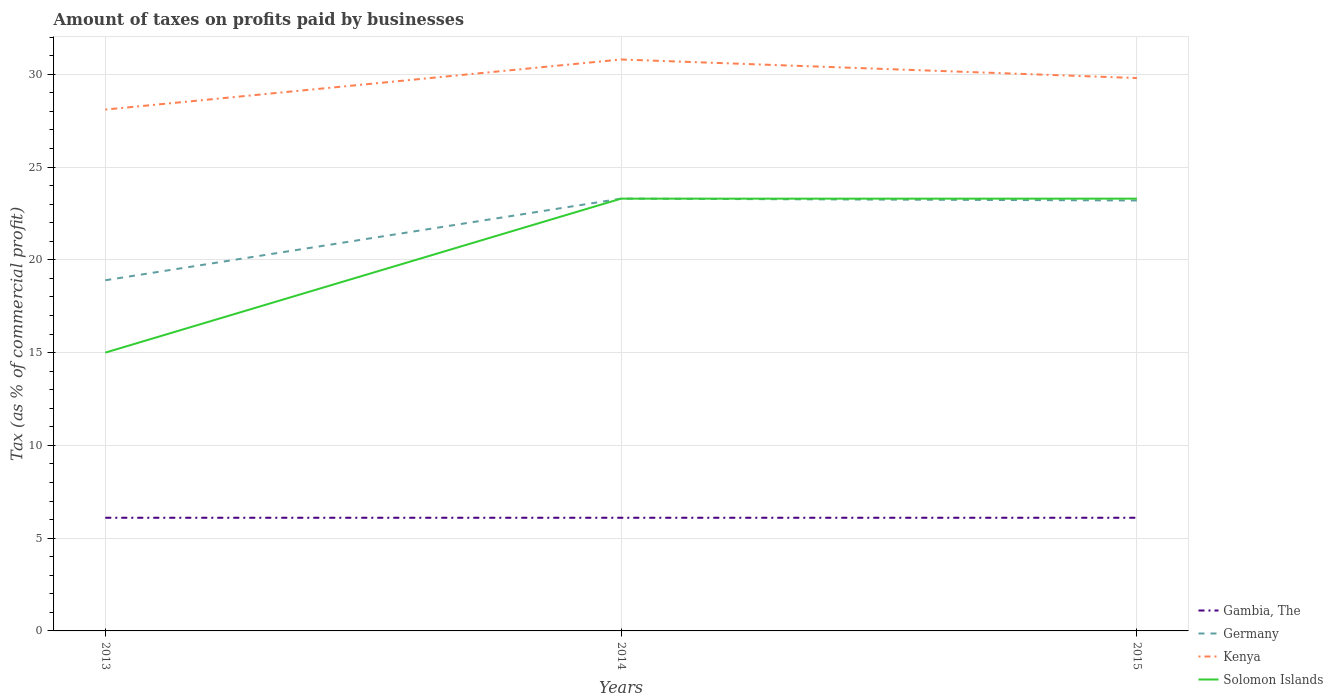Across all years, what is the maximum percentage of taxes paid by businesses in Germany?
Offer a terse response. 18.9. In which year was the percentage of taxes paid by businesses in Kenya maximum?
Keep it short and to the point. 2013. What is the total percentage of taxes paid by businesses in Germany in the graph?
Offer a terse response. 0.1. What is the difference between the highest and the second highest percentage of taxes paid by businesses in Kenya?
Make the answer very short. 2.7. Is the percentage of taxes paid by businesses in Germany strictly greater than the percentage of taxes paid by businesses in Kenya over the years?
Make the answer very short. Yes. Does the graph contain grids?
Your answer should be very brief. Yes. How many legend labels are there?
Your answer should be very brief. 4. How are the legend labels stacked?
Offer a terse response. Vertical. What is the title of the graph?
Your response must be concise. Amount of taxes on profits paid by businesses. What is the label or title of the Y-axis?
Ensure brevity in your answer.  Tax (as % of commercial profit). What is the Tax (as % of commercial profit) in Germany in 2013?
Give a very brief answer. 18.9. What is the Tax (as % of commercial profit) of Kenya in 2013?
Give a very brief answer. 28.1. What is the Tax (as % of commercial profit) of Germany in 2014?
Keep it short and to the point. 23.3. What is the Tax (as % of commercial profit) in Kenya in 2014?
Keep it short and to the point. 30.8. What is the Tax (as % of commercial profit) of Solomon Islands in 2014?
Keep it short and to the point. 23.3. What is the Tax (as % of commercial profit) of Germany in 2015?
Your answer should be compact. 23.2. What is the Tax (as % of commercial profit) of Kenya in 2015?
Ensure brevity in your answer.  29.8. What is the Tax (as % of commercial profit) of Solomon Islands in 2015?
Keep it short and to the point. 23.3. Across all years, what is the maximum Tax (as % of commercial profit) of Germany?
Give a very brief answer. 23.3. Across all years, what is the maximum Tax (as % of commercial profit) of Kenya?
Ensure brevity in your answer.  30.8. Across all years, what is the maximum Tax (as % of commercial profit) of Solomon Islands?
Provide a short and direct response. 23.3. Across all years, what is the minimum Tax (as % of commercial profit) of Gambia, The?
Ensure brevity in your answer.  6.1. Across all years, what is the minimum Tax (as % of commercial profit) of Kenya?
Your response must be concise. 28.1. What is the total Tax (as % of commercial profit) in Gambia, The in the graph?
Give a very brief answer. 18.3. What is the total Tax (as % of commercial profit) of Germany in the graph?
Keep it short and to the point. 65.4. What is the total Tax (as % of commercial profit) in Kenya in the graph?
Offer a very short reply. 88.7. What is the total Tax (as % of commercial profit) of Solomon Islands in the graph?
Provide a short and direct response. 61.6. What is the difference between the Tax (as % of commercial profit) of Gambia, The in 2013 and that in 2014?
Offer a terse response. 0. What is the difference between the Tax (as % of commercial profit) of Solomon Islands in 2013 and that in 2014?
Give a very brief answer. -8.3. What is the difference between the Tax (as % of commercial profit) of Gambia, The in 2013 and that in 2015?
Offer a very short reply. 0. What is the difference between the Tax (as % of commercial profit) in Solomon Islands in 2013 and that in 2015?
Provide a short and direct response. -8.3. What is the difference between the Tax (as % of commercial profit) in Gambia, The in 2014 and that in 2015?
Your answer should be compact. 0. What is the difference between the Tax (as % of commercial profit) in Solomon Islands in 2014 and that in 2015?
Keep it short and to the point. 0. What is the difference between the Tax (as % of commercial profit) of Gambia, The in 2013 and the Tax (as % of commercial profit) of Germany in 2014?
Give a very brief answer. -17.2. What is the difference between the Tax (as % of commercial profit) in Gambia, The in 2013 and the Tax (as % of commercial profit) in Kenya in 2014?
Offer a very short reply. -24.7. What is the difference between the Tax (as % of commercial profit) in Gambia, The in 2013 and the Tax (as % of commercial profit) in Solomon Islands in 2014?
Ensure brevity in your answer.  -17.2. What is the difference between the Tax (as % of commercial profit) of Germany in 2013 and the Tax (as % of commercial profit) of Kenya in 2014?
Provide a short and direct response. -11.9. What is the difference between the Tax (as % of commercial profit) in Germany in 2013 and the Tax (as % of commercial profit) in Solomon Islands in 2014?
Your answer should be very brief. -4.4. What is the difference between the Tax (as % of commercial profit) in Kenya in 2013 and the Tax (as % of commercial profit) in Solomon Islands in 2014?
Provide a succinct answer. 4.8. What is the difference between the Tax (as % of commercial profit) of Gambia, The in 2013 and the Tax (as % of commercial profit) of Germany in 2015?
Make the answer very short. -17.1. What is the difference between the Tax (as % of commercial profit) of Gambia, The in 2013 and the Tax (as % of commercial profit) of Kenya in 2015?
Ensure brevity in your answer.  -23.7. What is the difference between the Tax (as % of commercial profit) of Gambia, The in 2013 and the Tax (as % of commercial profit) of Solomon Islands in 2015?
Offer a very short reply. -17.2. What is the difference between the Tax (as % of commercial profit) of Germany in 2013 and the Tax (as % of commercial profit) of Kenya in 2015?
Offer a terse response. -10.9. What is the difference between the Tax (as % of commercial profit) of Germany in 2013 and the Tax (as % of commercial profit) of Solomon Islands in 2015?
Your answer should be very brief. -4.4. What is the difference between the Tax (as % of commercial profit) in Kenya in 2013 and the Tax (as % of commercial profit) in Solomon Islands in 2015?
Offer a terse response. 4.8. What is the difference between the Tax (as % of commercial profit) of Gambia, The in 2014 and the Tax (as % of commercial profit) of Germany in 2015?
Provide a short and direct response. -17.1. What is the difference between the Tax (as % of commercial profit) in Gambia, The in 2014 and the Tax (as % of commercial profit) in Kenya in 2015?
Offer a very short reply. -23.7. What is the difference between the Tax (as % of commercial profit) of Gambia, The in 2014 and the Tax (as % of commercial profit) of Solomon Islands in 2015?
Offer a very short reply. -17.2. What is the difference between the Tax (as % of commercial profit) of Germany in 2014 and the Tax (as % of commercial profit) of Kenya in 2015?
Give a very brief answer. -6.5. What is the difference between the Tax (as % of commercial profit) of Germany in 2014 and the Tax (as % of commercial profit) of Solomon Islands in 2015?
Provide a succinct answer. 0. What is the difference between the Tax (as % of commercial profit) of Kenya in 2014 and the Tax (as % of commercial profit) of Solomon Islands in 2015?
Your answer should be compact. 7.5. What is the average Tax (as % of commercial profit) of Gambia, The per year?
Provide a short and direct response. 6.1. What is the average Tax (as % of commercial profit) in Germany per year?
Provide a short and direct response. 21.8. What is the average Tax (as % of commercial profit) in Kenya per year?
Your answer should be compact. 29.57. What is the average Tax (as % of commercial profit) in Solomon Islands per year?
Provide a short and direct response. 20.53. In the year 2013, what is the difference between the Tax (as % of commercial profit) in Gambia, The and Tax (as % of commercial profit) in Germany?
Provide a succinct answer. -12.8. In the year 2013, what is the difference between the Tax (as % of commercial profit) of Germany and Tax (as % of commercial profit) of Solomon Islands?
Provide a succinct answer. 3.9. In the year 2013, what is the difference between the Tax (as % of commercial profit) in Kenya and Tax (as % of commercial profit) in Solomon Islands?
Ensure brevity in your answer.  13.1. In the year 2014, what is the difference between the Tax (as % of commercial profit) of Gambia, The and Tax (as % of commercial profit) of Germany?
Ensure brevity in your answer.  -17.2. In the year 2014, what is the difference between the Tax (as % of commercial profit) in Gambia, The and Tax (as % of commercial profit) in Kenya?
Give a very brief answer. -24.7. In the year 2014, what is the difference between the Tax (as % of commercial profit) of Gambia, The and Tax (as % of commercial profit) of Solomon Islands?
Give a very brief answer. -17.2. In the year 2015, what is the difference between the Tax (as % of commercial profit) of Gambia, The and Tax (as % of commercial profit) of Germany?
Offer a terse response. -17.1. In the year 2015, what is the difference between the Tax (as % of commercial profit) of Gambia, The and Tax (as % of commercial profit) of Kenya?
Make the answer very short. -23.7. In the year 2015, what is the difference between the Tax (as % of commercial profit) of Gambia, The and Tax (as % of commercial profit) of Solomon Islands?
Your response must be concise. -17.2. In the year 2015, what is the difference between the Tax (as % of commercial profit) in Germany and Tax (as % of commercial profit) in Kenya?
Offer a terse response. -6.6. In the year 2015, what is the difference between the Tax (as % of commercial profit) of Germany and Tax (as % of commercial profit) of Solomon Islands?
Offer a terse response. -0.1. In the year 2015, what is the difference between the Tax (as % of commercial profit) of Kenya and Tax (as % of commercial profit) of Solomon Islands?
Your answer should be compact. 6.5. What is the ratio of the Tax (as % of commercial profit) in Germany in 2013 to that in 2014?
Your response must be concise. 0.81. What is the ratio of the Tax (as % of commercial profit) of Kenya in 2013 to that in 2014?
Offer a terse response. 0.91. What is the ratio of the Tax (as % of commercial profit) of Solomon Islands in 2013 to that in 2014?
Provide a succinct answer. 0.64. What is the ratio of the Tax (as % of commercial profit) of Gambia, The in 2013 to that in 2015?
Provide a succinct answer. 1. What is the ratio of the Tax (as % of commercial profit) of Germany in 2013 to that in 2015?
Your answer should be very brief. 0.81. What is the ratio of the Tax (as % of commercial profit) in Kenya in 2013 to that in 2015?
Offer a terse response. 0.94. What is the ratio of the Tax (as % of commercial profit) of Solomon Islands in 2013 to that in 2015?
Ensure brevity in your answer.  0.64. What is the ratio of the Tax (as % of commercial profit) of Germany in 2014 to that in 2015?
Provide a succinct answer. 1. What is the ratio of the Tax (as % of commercial profit) in Kenya in 2014 to that in 2015?
Make the answer very short. 1.03. What is the ratio of the Tax (as % of commercial profit) in Solomon Islands in 2014 to that in 2015?
Offer a terse response. 1. What is the difference between the highest and the second highest Tax (as % of commercial profit) of Gambia, The?
Keep it short and to the point. 0. What is the difference between the highest and the lowest Tax (as % of commercial profit) of Germany?
Keep it short and to the point. 4.4. What is the difference between the highest and the lowest Tax (as % of commercial profit) in Kenya?
Your response must be concise. 2.7. What is the difference between the highest and the lowest Tax (as % of commercial profit) in Solomon Islands?
Make the answer very short. 8.3. 